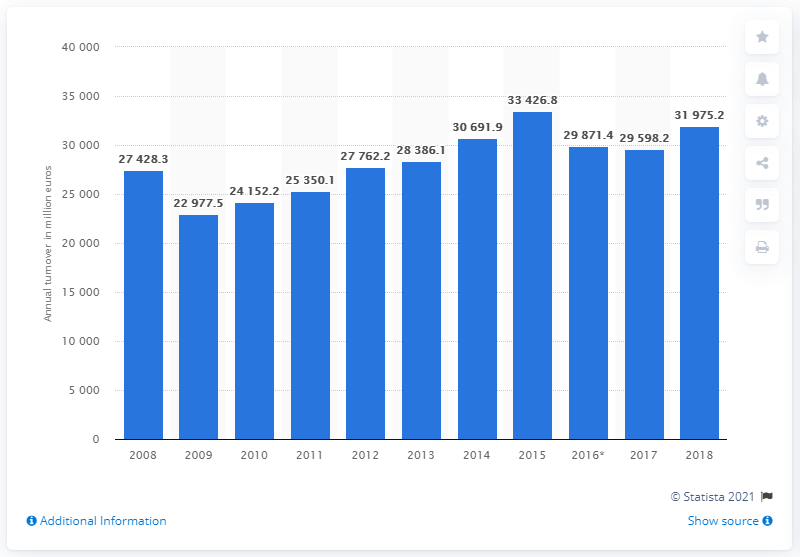Indicate a few pertinent items in this graphic. In 2018, the turnover of the air transport industry was 31,975.2 billion U.S. dollars. 